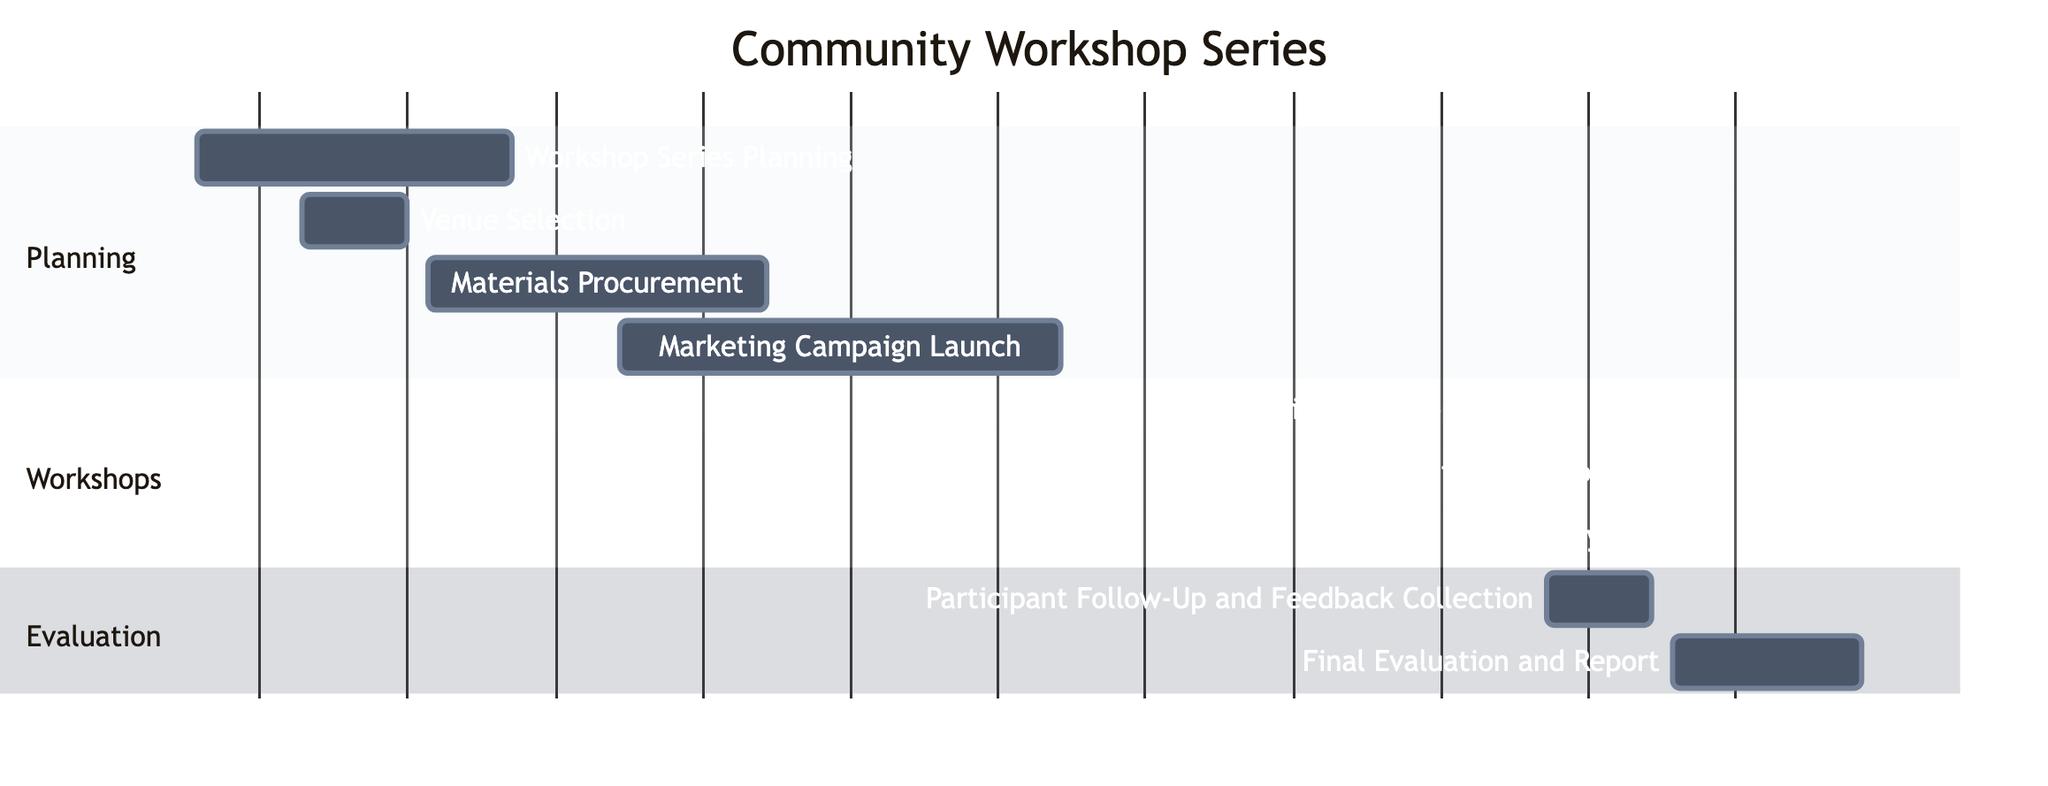What's the duration of the Workshop Series Planning task? The Workshop Series Planning task starts on January 5, 2023, and ends on January 20, 2023. To calculate the duration, subtract the start date from the end date, resulting in 15 days of planning.
Answer: 15 days What is the start date of Community Workshop 2? The diagram states that Community Workshop 2: Urban Sketching Techniques begins on February 27, 2023. Therefore, the start date is directly taken from the indicated date.
Answer: February 27, 2023 How many workshops are scheduled in total? The diagram lists three workshops: Community Workshop 1, Community Workshop 2, and Community Workshop 3. The total number of workshops is counted directly from the tasks under the Workshops section.
Answer: 3 workshops What is the end date for the Marketing Campaign Launch? The Marketing Campaign Launch task is documented to end on February 15, 2023. Therefore, this date is the answer to the question.
Answer: February 15, 2023 What task occurs immediately after Community Workshop 3? After Community Workshop 3, the next task listed in the timeline is Participant Follow-Up and Feedback Collection, which starts immediately on March 10, 2023, providing a seamless transition.
Answer: Participant Follow-Up and Feedback Collection 